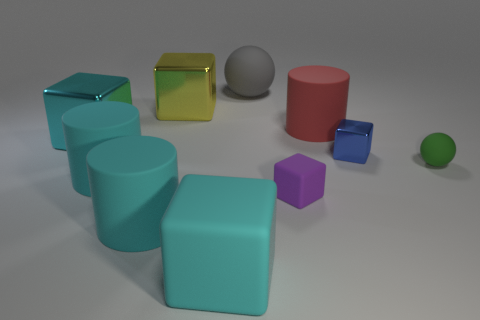Subtract all yellow cubes. How many cubes are left? 4 Subtract all blue metal blocks. How many blocks are left? 4 Subtract all blue cubes. Subtract all red cylinders. How many cubes are left? 4 Subtract all cylinders. How many objects are left? 7 Subtract 0 blue cylinders. How many objects are left? 10 Subtract all blue metallic cylinders. Subtract all rubber cylinders. How many objects are left? 7 Add 1 gray spheres. How many gray spheres are left? 2 Add 4 small purple rubber objects. How many small purple rubber objects exist? 5 